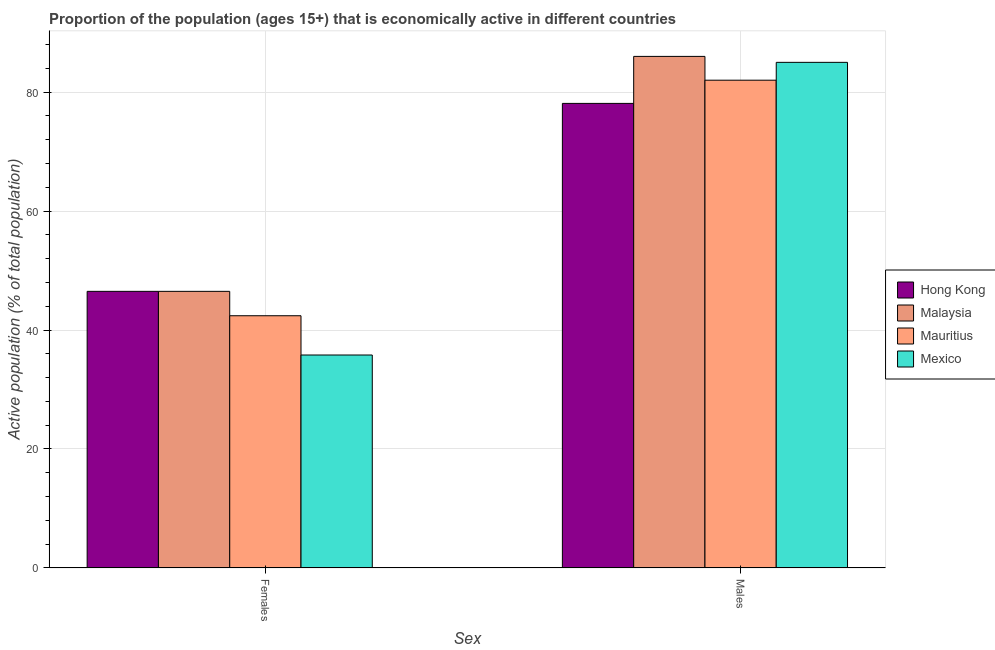How many different coloured bars are there?
Provide a succinct answer. 4. Are the number of bars on each tick of the X-axis equal?
Make the answer very short. Yes. How many bars are there on the 1st tick from the right?
Your response must be concise. 4. What is the label of the 1st group of bars from the left?
Your answer should be very brief. Females. What is the percentage of economically active female population in Mauritius?
Make the answer very short. 42.4. Across all countries, what is the maximum percentage of economically active male population?
Give a very brief answer. 86. Across all countries, what is the minimum percentage of economically active male population?
Keep it short and to the point. 78.1. In which country was the percentage of economically active female population maximum?
Your answer should be very brief. Hong Kong. What is the total percentage of economically active male population in the graph?
Provide a short and direct response. 331.1. What is the difference between the percentage of economically active male population in Mauritius and that in Malaysia?
Offer a very short reply. -4. What is the difference between the percentage of economically active female population in Malaysia and the percentage of economically active male population in Hong Kong?
Offer a terse response. -31.6. What is the average percentage of economically active male population per country?
Provide a succinct answer. 82.77. What is the difference between the percentage of economically active female population and percentage of economically active male population in Hong Kong?
Your response must be concise. -31.6. In how many countries, is the percentage of economically active female population greater than 64 %?
Keep it short and to the point. 0. What is the ratio of the percentage of economically active male population in Mauritius to that in Hong Kong?
Keep it short and to the point. 1.05. Is the percentage of economically active male population in Mexico less than that in Malaysia?
Provide a succinct answer. Yes. In how many countries, is the percentage of economically active female population greater than the average percentage of economically active female population taken over all countries?
Your answer should be very brief. 2. What is the difference between two consecutive major ticks on the Y-axis?
Make the answer very short. 20. Are the values on the major ticks of Y-axis written in scientific E-notation?
Your response must be concise. No. Does the graph contain any zero values?
Your answer should be very brief. No. Where does the legend appear in the graph?
Your response must be concise. Center right. What is the title of the graph?
Ensure brevity in your answer.  Proportion of the population (ages 15+) that is economically active in different countries. Does "Burundi" appear as one of the legend labels in the graph?
Offer a very short reply. No. What is the label or title of the X-axis?
Your answer should be compact. Sex. What is the label or title of the Y-axis?
Offer a terse response. Active population (% of total population). What is the Active population (% of total population) in Hong Kong in Females?
Offer a very short reply. 46.5. What is the Active population (% of total population) in Malaysia in Females?
Your answer should be very brief. 46.5. What is the Active population (% of total population) of Mauritius in Females?
Keep it short and to the point. 42.4. What is the Active population (% of total population) in Mexico in Females?
Provide a succinct answer. 35.8. What is the Active population (% of total population) in Hong Kong in Males?
Your answer should be compact. 78.1. What is the Active population (% of total population) of Malaysia in Males?
Provide a succinct answer. 86. What is the Active population (% of total population) of Mauritius in Males?
Keep it short and to the point. 82. What is the Active population (% of total population) of Mexico in Males?
Provide a short and direct response. 85. Across all Sex, what is the maximum Active population (% of total population) of Hong Kong?
Provide a succinct answer. 78.1. Across all Sex, what is the maximum Active population (% of total population) in Malaysia?
Provide a short and direct response. 86. Across all Sex, what is the maximum Active population (% of total population) of Mauritius?
Give a very brief answer. 82. Across all Sex, what is the minimum Active population (% of total population) of Hong Kong?
Offer a very short reply. 46.5. Across all Sex, what is the minimum Active population (% of total population) of Malaysia?
Offer a terse response. 46.5. Across all Sex, what is the minimum Active population (% of total population) of Mauritius?
Provide a succinct answer. 42.4. Across all Sex, what is the minimum Active population (% of total population) of Mexico?
Provide a short and direct response. 35.8. What is the total Active population (% of total population) of Hong Kong in the graph?
Your answer should be very brief. 124.6. What is the total Active population (% of total population) of Malaysia in the graph?
Ensure brevity in your answer.  132.5. What is the total Active population (% of total population) of Mauritius in the graph?
Ensure brevity in your answer.  124.4. What is the total Active population (% of total population) in Mexico in the graph?
Provide a succinct answer. 120.8. What is the difference between the Active population (% of total population) of Hong Kong in Females and that in Males?
Provide a short and direct response. -31.6. What is the difference between the Active population (% of total population) of Malaysia in Females and that in Males?
Keep it short and to the point. -39.5. What is the difference between the Active population (% of total population) of Mauritius in Females and that in Males?
Make the answer very short. -39.6. What is the difference between the Active population (% of total population) of Mexico in Females and that in Males?
Give a very brief answer. -49.2. What is the difference between the Active population (% of total population) in Hong Kong in Females and the Active population (% of total population) in Malaysia in Males?
Give a very brief answer. -39.5. What is the difference between the Active population (% of total population) of Hong Kong in Females and the Active population (% of total population) of Mauritius in Males?
Provide a succinct answer. -35.5. What is the difference between the Active population (% of total population) in Hong Kong in Females and the Active population (% of total population) in Mexico in Males?
Provide a short and direct response. -38.5. What is the difference between the Active population (% of total population) of Malaysia in Females and the Active population (% of total population) of Mauritius in Males?
Provide a succinct answer. -35.5. What is the difference between the Active population (% of total population) of Malaysia in Females and the Active population (% of total population) of Mexico in Males?
Your answer should be compact. -38.5. What is the difference between the Active population (% of total population) in Mauritius in Females and the Active population (% of total population) in Mexico in Males?
Make the answer very short. -42.6. What is the average Active population (% of total population) in Hong Kong per Sex?
Offer a terse response. 62.3. What is the average Active population (% of total population) of Malaysia per Sex?
Ensure brevity in your answer.  66.25. What is the average Active population (% of total population) of Mauritius per Sex?
Ensure brevity in your answer.  62.2. What is the average Active population (% of total population) in Mexico per Sex?
Give a very brief answer. 60.4. What is the difference between the Active population (% of total population) in Hong Kong and Active population (% of total population) in Malaysia in Females?
Provide a short and direct response. 0. What is the difference between the Active population (% of total population) in Malaysia and Active population (% of total population) in Mexico in Females?
Make the answer very short. 10.7. What is the difference between the Active population (% of total population) in Hong Kong and Active population (% of total population) in Mexico in Males?
Offer a very short reply. -6.9. What is the difference between the Active population (% of total population) in Malaysia and Active population (% of total population) in Mauritius in Males?
Give a very brief answer. 4. What is the difference between the Active population (% of total population) of Malaysia and Active population (% of total population) of Mexico in Males?
Offer a terse response. 1. What is the ratio of the Active population (% of total population) of Hong Kong in Females to that in Males?
Ensure brevity in your answer.  0.6. What is the ratio of the Active population (% of total population) of Malaysia in Females to that in Males?
Make the answer very short. 0.54. What is the ratio of the Active population (% of total population) in Mauritius in Females to that in Males?
Give a very brief answer. 0.52. What is the ratio of the Active population (% of total population) in Mexico in Females to that in Males?
Keep it short and to the point. 0.42. What is the difference between the highest and the second highest Active population (% of total population) of Hong Kong?
Your answer should be compact. 31.6. What is the difference between the highest and the second highest Active population (% of total population) of Malaysia?
Provide a short and direct response. 39.5. What is the difference between the highest and the second highest Active population (% of total population) of Mauritius?
Your answer should be very brief. 39.6. What is the difference between the highest and the second highest Active population (% of total population) of Mexico?
Offer a terse response. 49.2. What is the difference between the highest and the lowest Active population (% of total population) of Hong Kong?
Make the answer very short. 31.6. What is the difference between the highest and the lowest Active population (% of total population) in Malaysia?
Your response must be concise. 39.5. What is the difference between the highest and the lowest Active population (% of total population) of Mauritius?
Provide a short and direct response. 39.6. What is the difference between the highest and the lowest Active population (% of total population) of Mexico?
Keep it short and to the point. 49.2. 